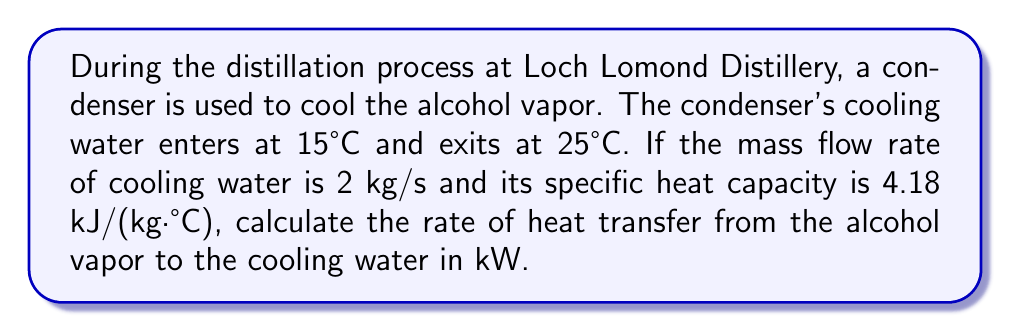Solve this math problem. To solve this problem, we'll use the heat transfer equation for fluids:

$$Q = \dot{m} \cdot c_p \cdot \Delta T$$

Where:
$Q$ = rate of heat transfer (kW)
$\dot{m}$ = mass flow rate of cooling water (kg/s)
$c_p$ = specific heat capacity of water (kJ/(kg·°C))
$\Delta T$ = temperature difference between inlet and outlet (°C)

Step 1: Identify the given values
$\dot{m} = 2$ kg/s
$c_p = 4.18$ kJ/(kg·°C)
$T_{inlet} = 15°C$
$T_{outlet} = 25°C$

Step 2: Calculate $\Delta T$
$$\Delta T = T_{outlet} - T_{inlet} = 25°C - 15°C = 10°C$$

Step 3: Apply the heat transfer equation
$$Q = 2 \text{ kg/s} \cdot 4.18 \text{ kJ/(kg·°C)} \cdot 10°C$$

Step 4: Calculate the result
$$Q = 83.6 \text{ kJ/s} = 83.6 \text{ kW}$$

Therefore, the rate of heat transfer from the alcohol vapor to the cooling water is 83.6 kW.
Answer: 83.6 kW 